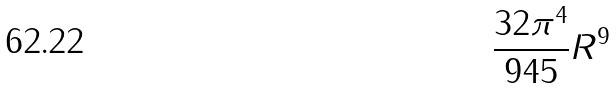<formula> <loc_0><loc_0><loc_500><loc_500>\frac { 3 2 \pi ^ { 4 } } { 9 4 5 } R ^ { 9 }</formula> 